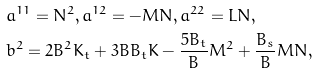Convert formula to latex. <formula><loc_0><loc_0><loc_500><loc_500>& a ^ { 1 1 } = N ^ { 2 } , a ^ { 1 2 } = - M N , a ^ { 2 2 } = L N , \\ & b ^ { 2 } = 2 B ^ { 2 } K _ { t } + 3 B B _ { t } K - \frac { 5 B _ { t } } { B } M ^ { 2 } + \frac { B _ { s } } { B } M N ,</formula> 